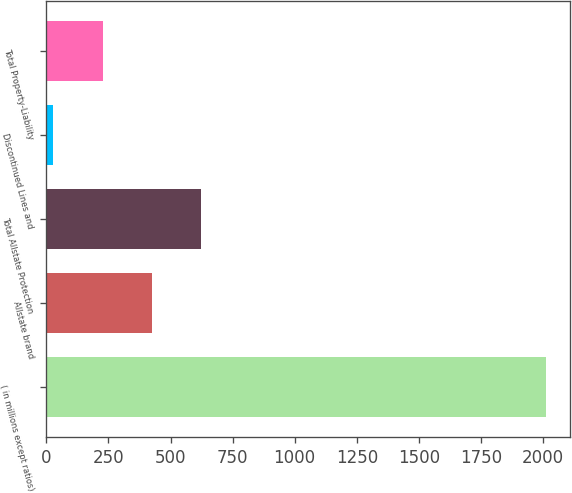Convert chart. <chart><loc_0><loc_0><loc_500><loc_500><bar_chart><fcel>( in millions except ratios)<fcel>Allstate brand<fcel>Total Allstate Protection<fcel>Discontinued Lines and<fcel>Total Property-Liability<nl><fcel>2010<fcel>424.4<fcel>622.6<fcel>28<fcel>226.2<nl></chart> 